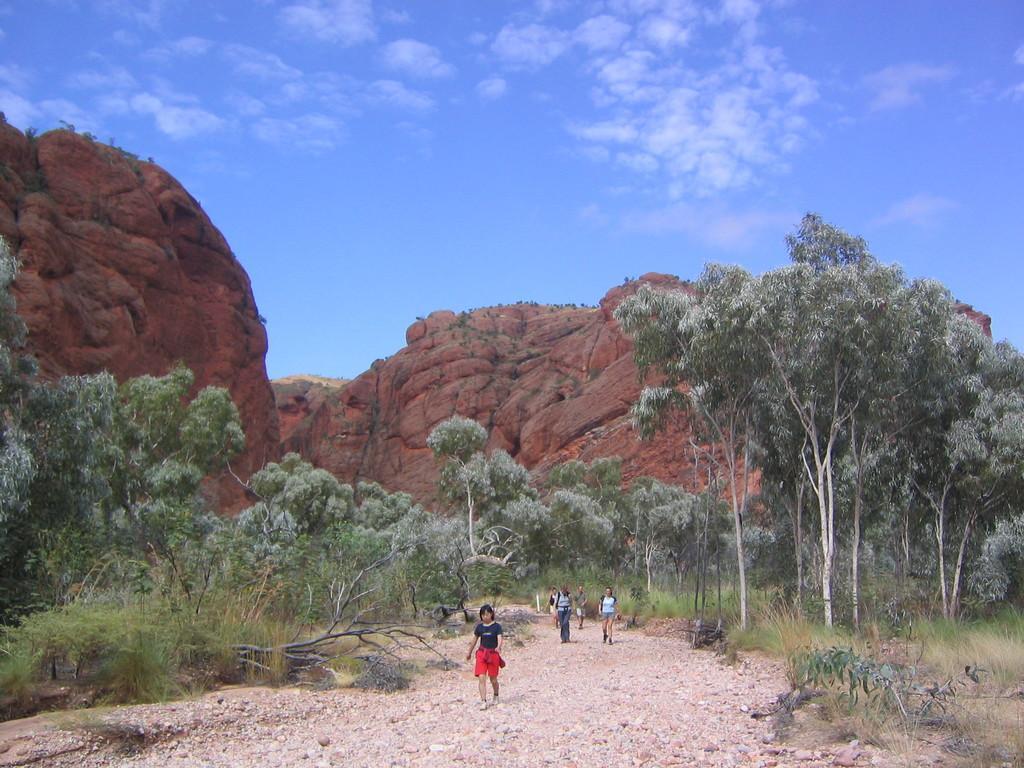Could you give a brief overview of what you see in this image? In this picture we can see people on the ground and in the background we can see trees, rocks and sky with clouds. 